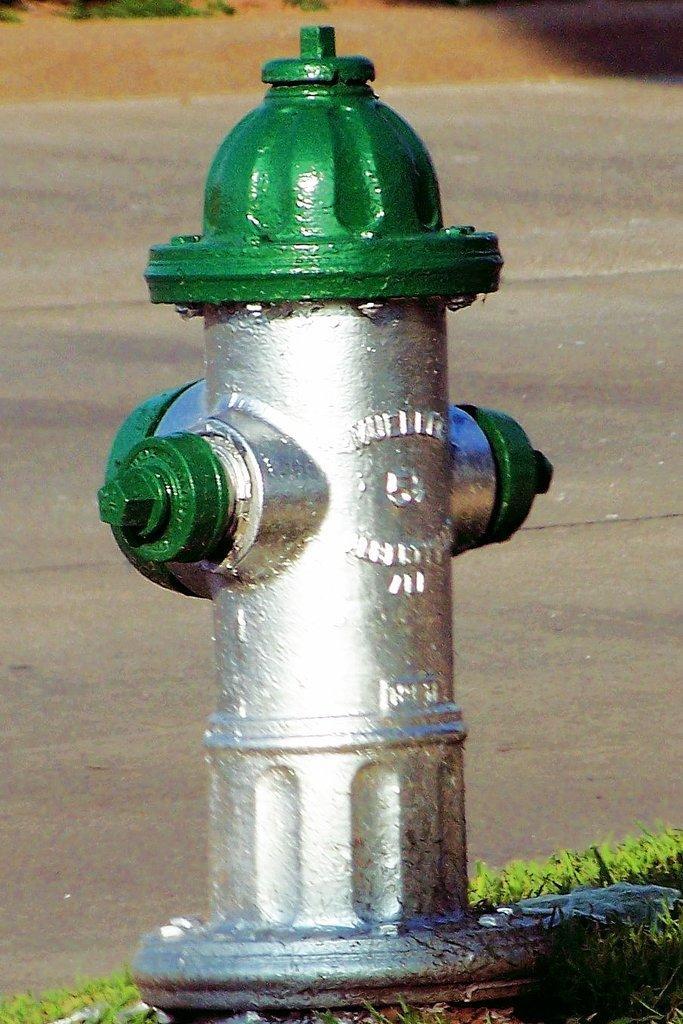Can you describe this image briefly? In this picture I can observe a fire hydrant in the middle of the picture. It is in green and silver color. In the background I can observe road. 